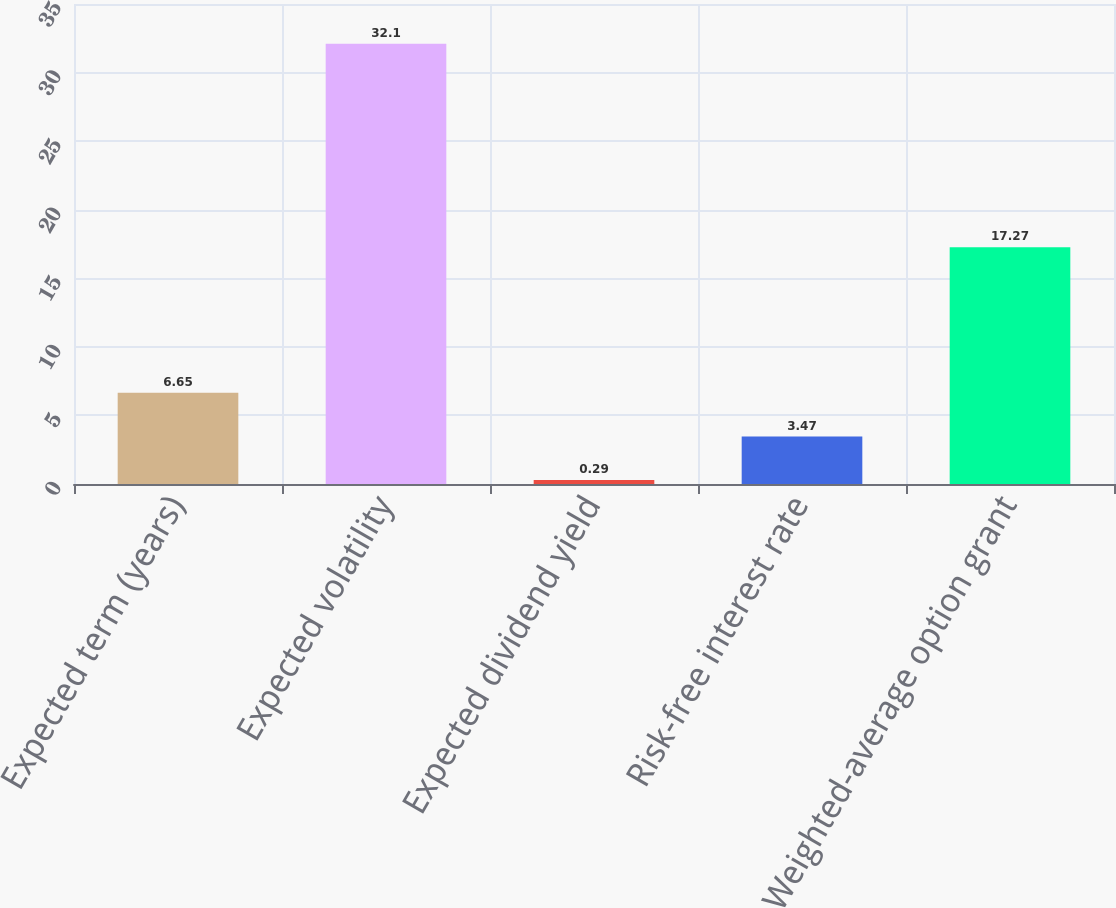Convert chart. <chart><loc_0><loc_0><loc_500><loc_500><bar_chart><fcel>Expected term (years)<fcel>Expected volatility<fcel>Expected dividend yield<fcel>Risk-free interest rate<fcel>Weighted-average option grant<nl><fcel>6.65<fcel>32.1<fcel>0.29<fcel>3.47<fcel>17.27<nl></chart> 